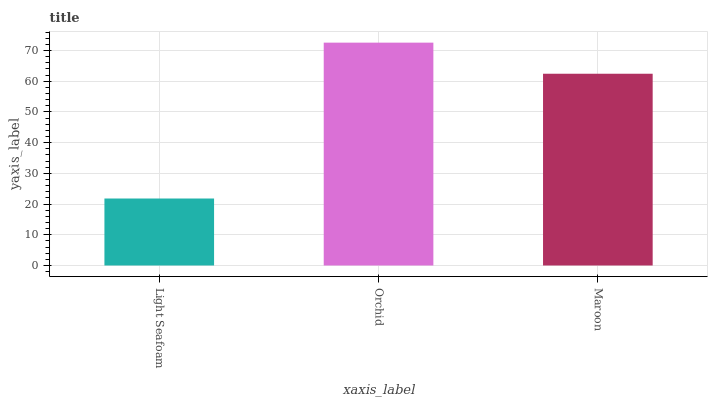Is Light Seafoam the minimum?
Answer yes or no. Yes. Is Orchid the maximum?
Answer yes or no. Yes. Is Maroon the minimum?
Answer yes or no. No. Is Maroon the maximum?
Answer yes or no. No. Is Orchid greater than Maroon?
Answer yes or no. Yes. Is Maroon less than Orchid?
Answer yes or no. Yes. Is Maroon greater than Orchid?
Answer yes or no. No. Is Orchid less than Maroon?
Answer yes or no. No. Is Maroon the high median?
Answer yes or no. Yes. Is Maroon the low median?
Answer yes or no. Yes. Is Light Seafoam the high median?
Answer yes or no. No. Is Light Seafoam the low median?
Answer yes or no. No. 